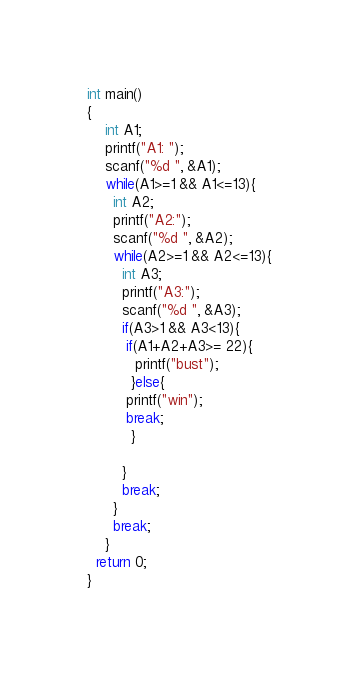<code> <loc_0><loc_0><loc_500><loc_500><_C++_>int main()
{
    int A1;
    printf("A1: ");
    scanf("%d ", &A1);
    while(A1>=1 && A1<=13){
      int A2;
      printf("A2:");
      scanf("%d ", &A2);
      while(A2>=1 && A2<=13){
        int A3;
        printf("A3:");
        scanf("%d ", &A3);
        if(A3>1 && A3<13){
         if(A1+A2+A3>= 22){
           printf("bust");
          }else{
         printf("win");
         break;
          }

        }
        break;
      }
      break;
    }
  return 0;
}</code> 